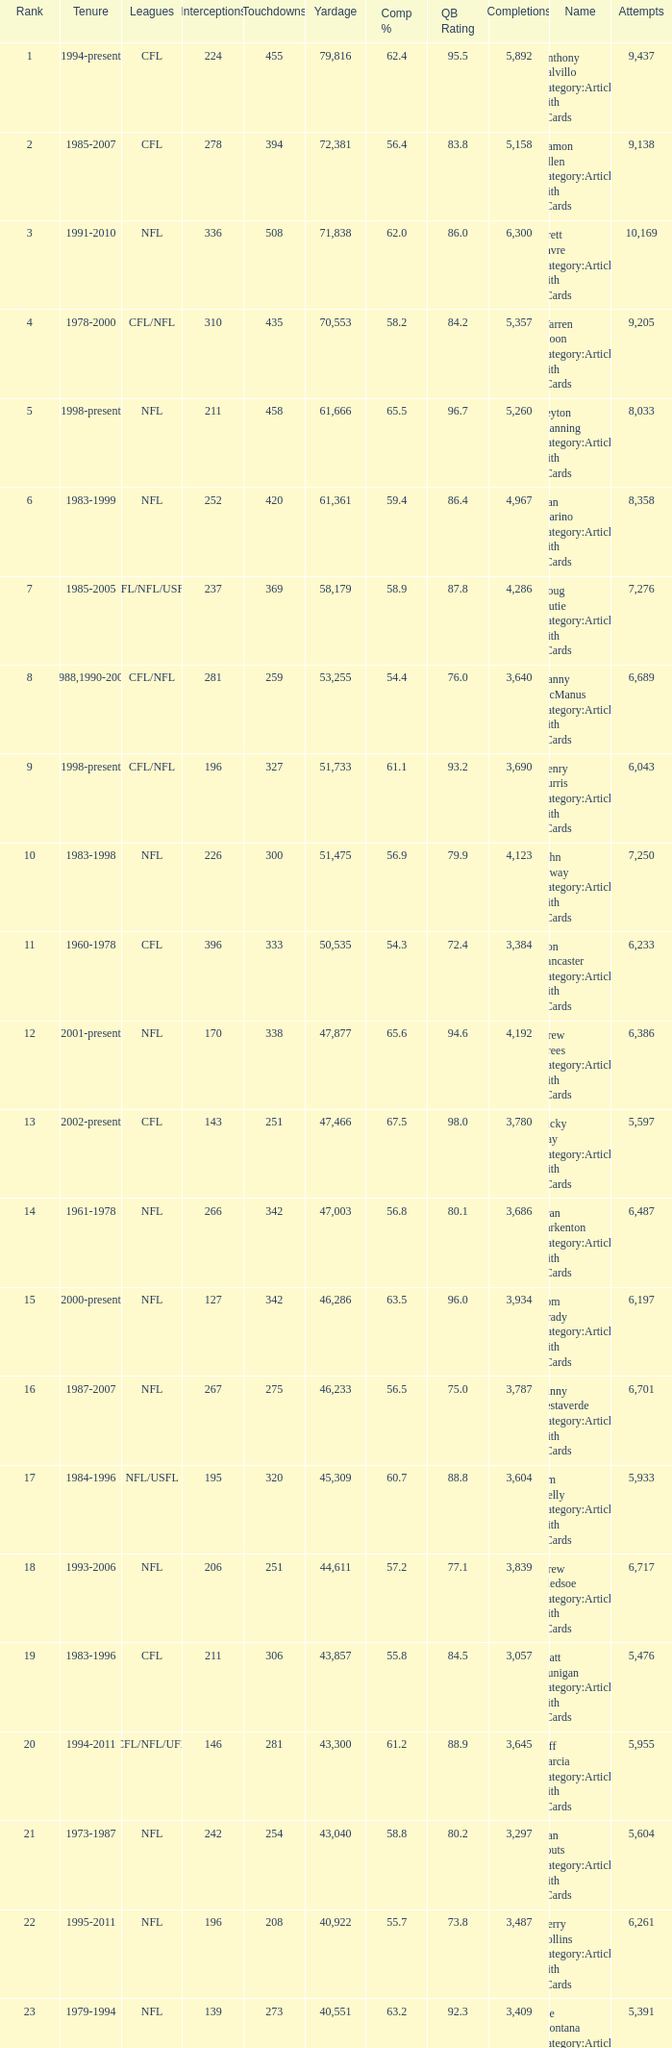What is the number of interceptions with less than 3,487 completions , more than 40,551 yardage, and the comp % is 55.8? 211.0. 